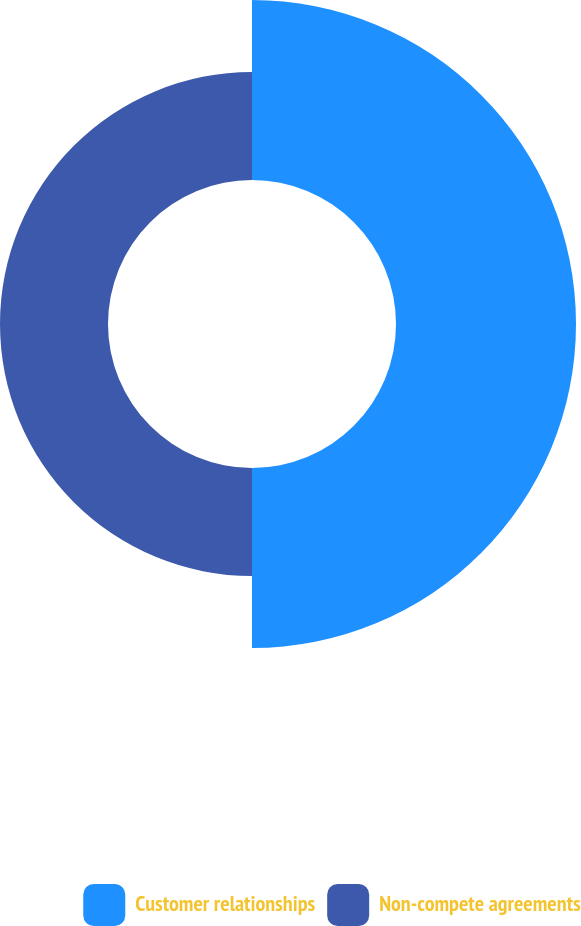<chart> <loc_0><loc_0><loc_500><loc_500><pie_chart><fcel>Customer relationships<fcel>Non-compete agreements<nl><fcel>62.5%<fcel>37.5%<nl></chart> 